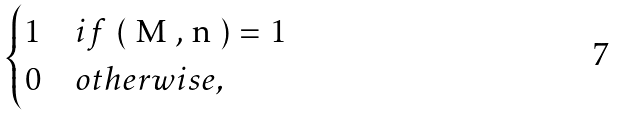<formula> <loc_0><loc_0><loc_500><loc_500>\begin{cases} 1 & i f $ ( M , n ) = 1 $ \\ 0 & o t h e r w i s e , \end{cases}</formula> 